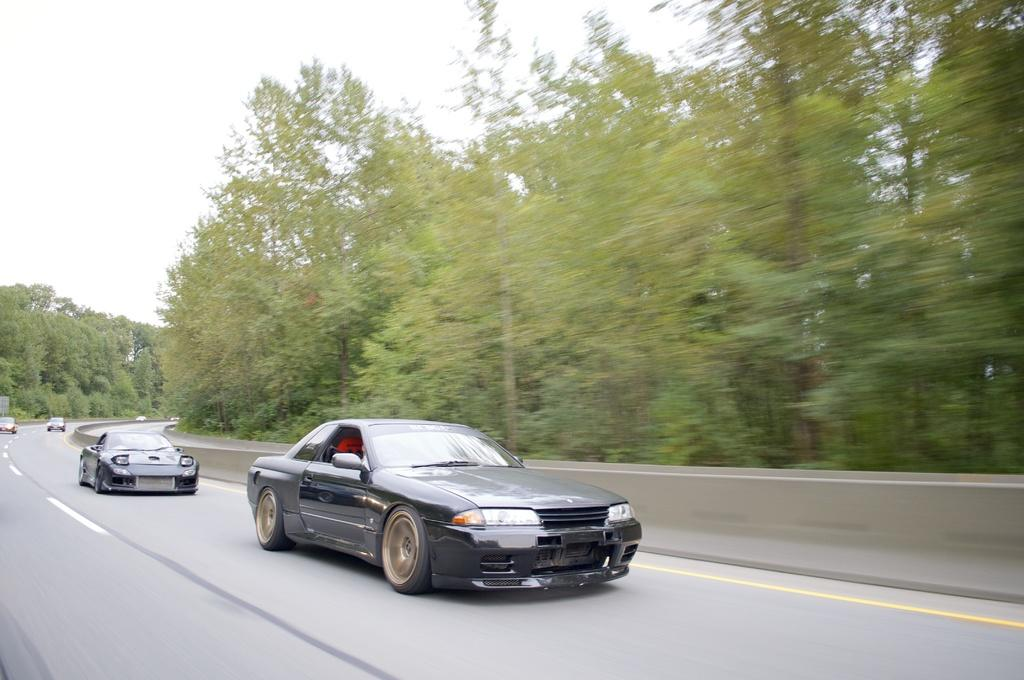What can be seen at the bottom of the image? There are cars on the road at the bottom of the image. What type of vegetation is visible in the background of the image? There are trees in the background of the image. What is visible at the top of the image? The sky is visible at the top of the image. How many stockings are hanging from the trees in the image? There are no stockings hanging from the trees in the image; it only features cars, trees, and the sky. Are there any bikes visible in the image? There is no mention of bikes in the provided facts, and therefore we cannot determine if they are present in the image. 